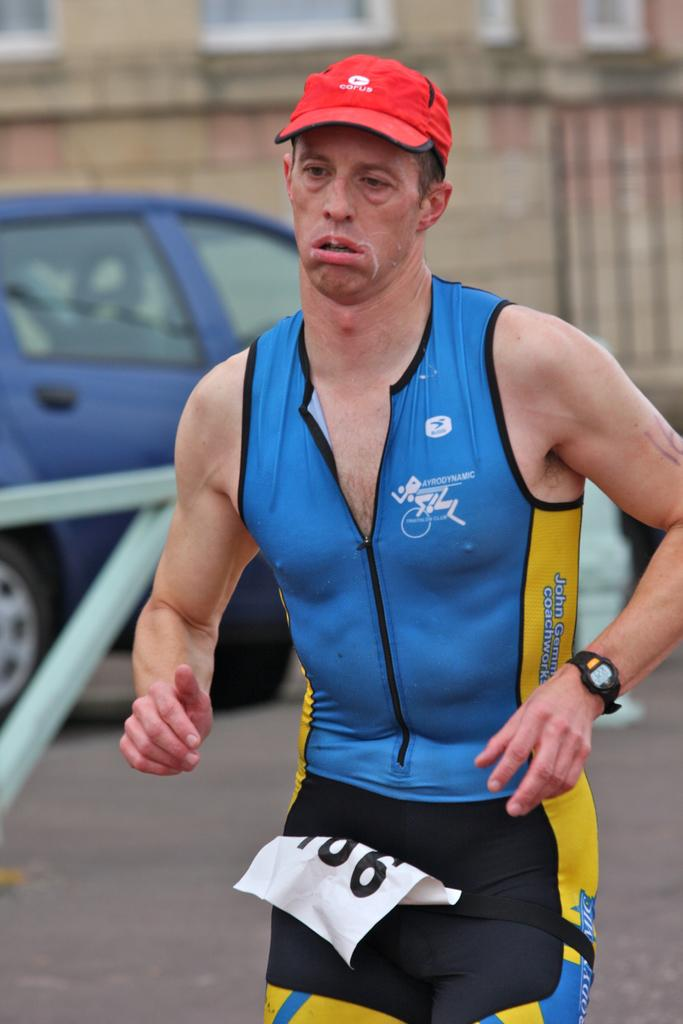<image>
Summarize the visual content of the image. a man running in a race with a red cap and a blue shirt that says ayrodynamic on it. 